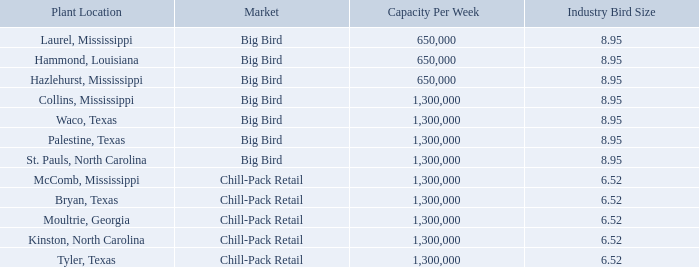Markets and Pricing
The three largest customer markets in the fresh and frozen chicken industry are food service customers that purchase fresh, bulk-packed products produced from a relatively big bird, retail grocery store customers that purchase fresh, tray- packed products produced from a medium-sized bird, and quick-serve food service customers that purchase products produced from relatively small birds.
The following table sets forth, for each of the Company’s poultry processing plants, the general customer market to which the plant is devoted, the weekly capacity of each plant at full capacity expressed in number of head processed, and the industry's average size of birds processed in the relevant market.
Our big bird plants process a relatively large bird. The chicken products produced at these plants is generally sold as fresh, bulk-packed chicken cut into a variety of products, including boneless breast meat, chicken tenders, whole and cut wings and boneless thigh meat, and is sold primarily to restaurants, food service customers and further processors at negotiated spreads from quoted commodity market prices for those products. We have long-term contracts with many of our customers for these products produced at our big bird plants, but prices for products sold pursuant to those contracts fluctuate based on quoted commodity market prices. The contracts do not require the customers to purchase, or the Company to sell, any specific quantity of product. The dark meat from these birds that is not deboned is sold primarily as frozen leg quarters in the export market or as fresh whole legs to further processors. While we have long-standing relationships with many of our export partners, virtually all of our export sales are at negotiated or spot commodity prices, which prices exhibit fluctuations typical of commodity markets. We have few long-term contracts for this product.
As of October 31, 2019, the Company had the capacity to process 7.1 million head per week in its big bird plants, and its results are materially affected by fluctuations in the commodity market prices for boneless breast meat, chicken tenders, wings, leg quarters and boneless thigh meat as quoted by Urner Barry.
Urner Barry is an independent company specializing in the timely, accurate and independent reporting on market news and market price quotations to its customers in various food and protein industries, including poultry. The Urner Barry spot market prices for boneless breast meat, chicken tenders, leg quarters, whole wings and boneless thighs for the past five calendar years are set forth below and are published with Urner Barry's permission. Realized prices will not necessarily equal quoted market prices since most contracts offer negotiated discounts to quoted market prices, which discounts are negotiated on a customer by customer basis and are influenced by many factors. Selection of a particular market price benchmark is largely customer driven:
Our chill-pack plants process medium sized birds and cut and package the product in various sized individual trays to customers’ specifications. The trays are weighed and pre-priced primarily for customers to resell through retail grocery outlets. While the Company sells some of its chill-pack product under store brand names, most of its chill-pack production is sold under the Company’s Sanderson Farms® brand name. The Company has long-term contracts with most of its chill-pack customers. These agreements typically provide for the pricing of product based on agreed upon, flat prices or on negotiated formulas that use an agreed upon, regularly quoted market price as the base, as well as various other guidelines for the relationship between the parties. All of our contracts with retail grocery store customers also provide for the sale of negotiated quantities of product at periodically negotiated prices, rather than the flat and formula-driven prices discussed above. None of our contracts with retail grocery store customers require the customers to purchase, or the Company to sell, any specific quantity of product. As of October 31, 2019, the Company had the capacity to process 6.5 million head per week at its chill-pack plants, and its results are materially affected by fluctuations in Urner Barry prices and other market benchmarks.
As with products produced at our big bird plants, selection of the desired methodology for pricing chill-pack products is largely customer driven. Prior to the discontinuation in November 2016 of the Georgia Dock index, which had been published by the Georgia Department of Agriculture, many of our chill-pack customers used that index as the base for pricing formulas. As new and renewing contracts have been negotiated, many of our chill-pack customers chose to negotiate flat prices for the life of the contracts, while some of our customers have chosen to use an index published by Express Markets, Inc. ("EMI").
Almost all of our products sold by our prepared chicken plant are sold under long-term contracts at fixed prices related to the spot commodity price of chicken at the time the contract is negotiated, plus a premium for additional processing.
What is the capacity per week for the plants at Laurel, Mississippi and Hammond, Louisiana respectively? 650,000, 650,000. What is the capacity per week for the plants at Hazlehurst, Mississippi and Collins, Mississippi respectively? 650,000, 1,300,000. What is the industry bird size processed for the plants at Laurel, Mississippi and Hammond, Louisiana respectively? 8.95, 8.95. How many plant locations have a capacity per week of 650,000? Laurel, Mississippi ## Hammond, Louisiana ## Hazlehurst, Mississippi
Answer: 3. What is the difference in capacity per week between the processing plants at Laurel, Mississippi and Collins, Mississippi?  1,300,000-650,000
Answer: 650000. What is the difference in the industry bird size processed at Palestine, Texas compared to those at Bryan, Texas? 8.95-6.52
Answer: 2.43. 